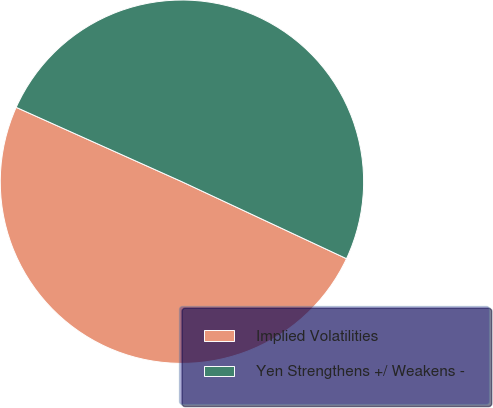Convert chart. <chart><loc_0><loc_0><loc_500><loc_500><pie_chart><fcel>Implied Volatilities<fcel>Yen Strengthens +/ Weakens -<nl><fcel>49.75%<fcel>50.25%<nl></chart> 